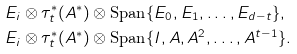Convert formula to latex. <formula><loc_0><loc_0><loc_500><loc_500>& E _ { i } \otimes \tau ^ { * } _ { t } ( A ^ { * } ) \otimes \text {Span} \{ E _ { 0 } , E _ { 1 } , \dots , E _ { d - t } \} , \\ & E _ { i } \otimes \tau ^ { * } _ { t } ( A ^ { * } ) \otimes \text {Span} \{ I , A , A ^ { 2 } , \dots , A ^ { t - 1 } \} .</formula> 